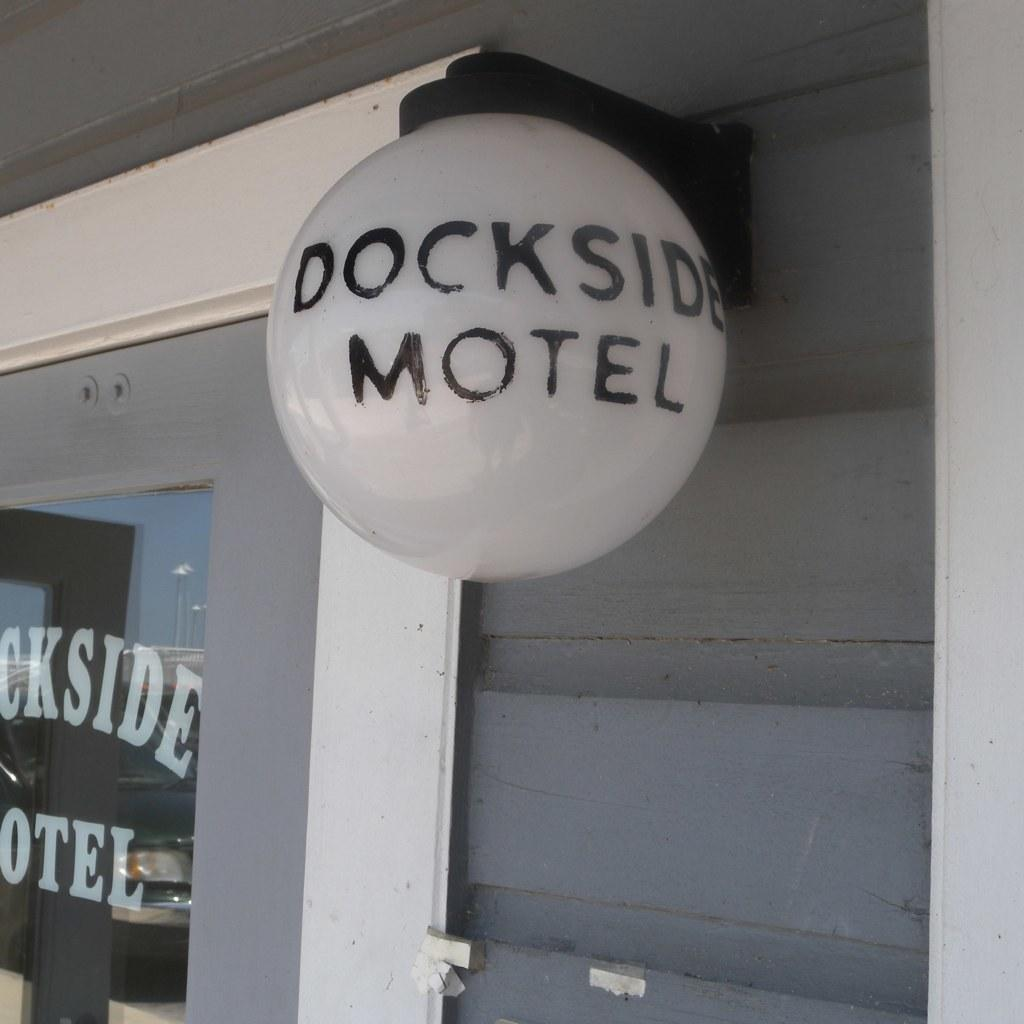What object in the image has words written on it? There are words written on a bulb and a glass door in the image. What type of surface is visible in the image? There is a wall visible in the image. What type of art can be seen on the wall in the image? There is no art visible on the wall in the image; only words written on a bulb and a glass door are present. 